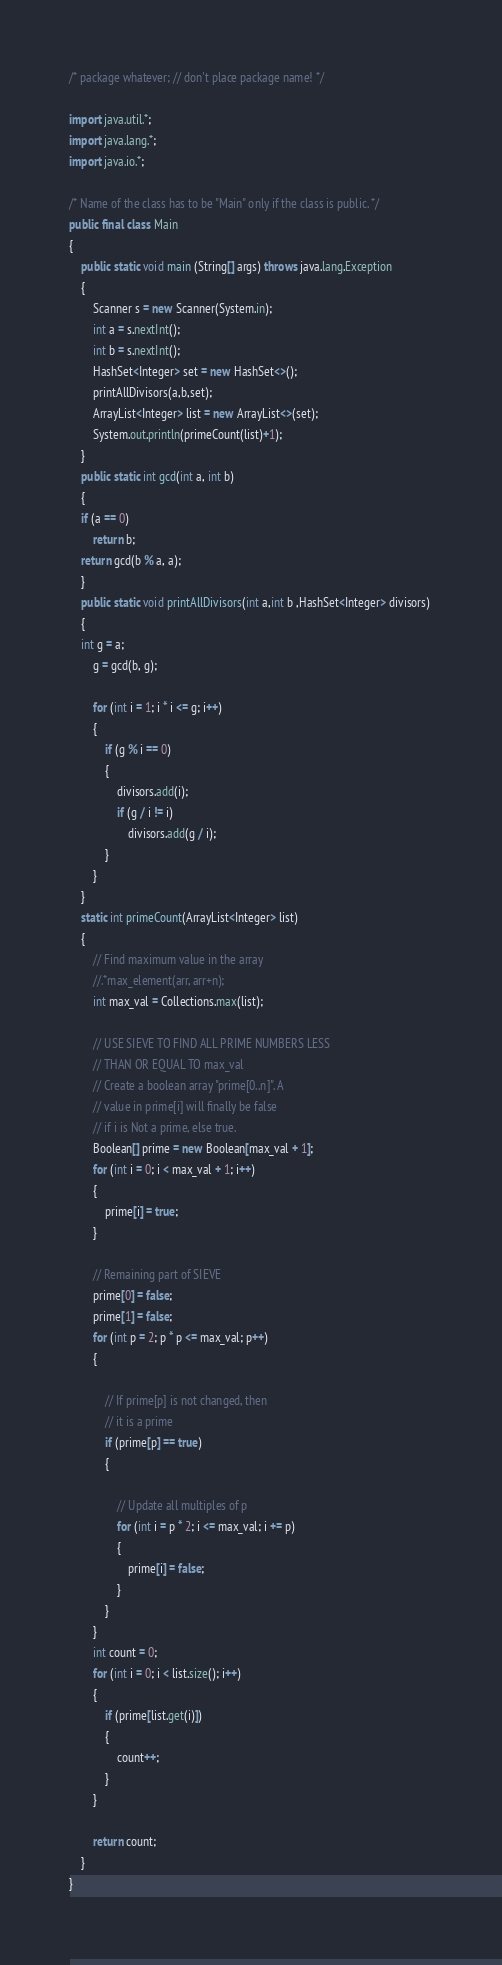<code> <loc_0><loc_0><loc_500><loc_500><_Java_>/* package whatever; // don't place package name! */

import java.util.*;
import java.lang.*;
import java.io.*;

/* Name of the class has to be "Main" only if the class is public. */
public final class Main
{
	public static void main (String[] args) throws java.lang.Exception
	{
		Scanner s = new Scanner(System.in);
		int a = s.nextInt();
		int b = s.nextInt();
		HashSet<Integer> set = new HashSet<>();
		printAllDivisors(a,b,set);
		ArrayList<Integer> list = new ArrayList<>(set);
        System.out.println(primeCount(list)+1);
	}
    public static int gcd(int a, int b) 
    { 
    if (a == 0) 
        return b; 
    return gcd(b % a, a); 
    } 
    public static void printAllDivisors(int a,int b ,HashSet<Integer> divisors) 
    {    
    int g = a; 
        g = gcd(b, g); 
 
        for (int i = 1; i * i <= g; i++) 
        { 
            if (g % i == 0)  
            { 
                divisors.add(i); 
                if (g / i != i) 
                    divisors.add(g / i); 
            } 
        }
    } 
    static int primeCount(ArrayList<Integer> list) 
    { 
        // Find maximum value in the array 
        //.*max_element(arr, arr+n); 
        int max_val = Collections.max(list); 
  
        // USE SIEVE TO FIND ALL PRIME NUMBERS LESS 
        // THAN OR EQUAL TO max_val 
        // Create a boolean array "prime[0..n]". A 
        // value in prime[i] will finally be false 
        // if i is Not a prime, else true. 
        Boolean[] prime = new Boolean[max_val + 1]; 
        for (int i = 0; i < max_val + 1; i++)  
        { 
            prime[i] = true; 
        } 
  
        // Remaining part of SIEVE 
        prime[0] = false; 
        prime[1] = false; 
        for (int p = 2; p * p <= max_val; p++)  
        { 
  
            // If prime[p] is not changed, then 
            // it is a prime 
            if (prime[p] == true)  
            { 
  
                // Update all multiples of p 
                for (int i = p * 2; i <= max_val; i += p) 
                { 
                    prime[i] = false; 
                } 
            } 
        } 
        int count = 0; 
        for (int i = 0; i < list.size(); i++) 
        { 
            if (prime[list.get(i)]) 
            { 
                count++; 
            } 
        } 
  
        return count; 
    } 
}</code> 